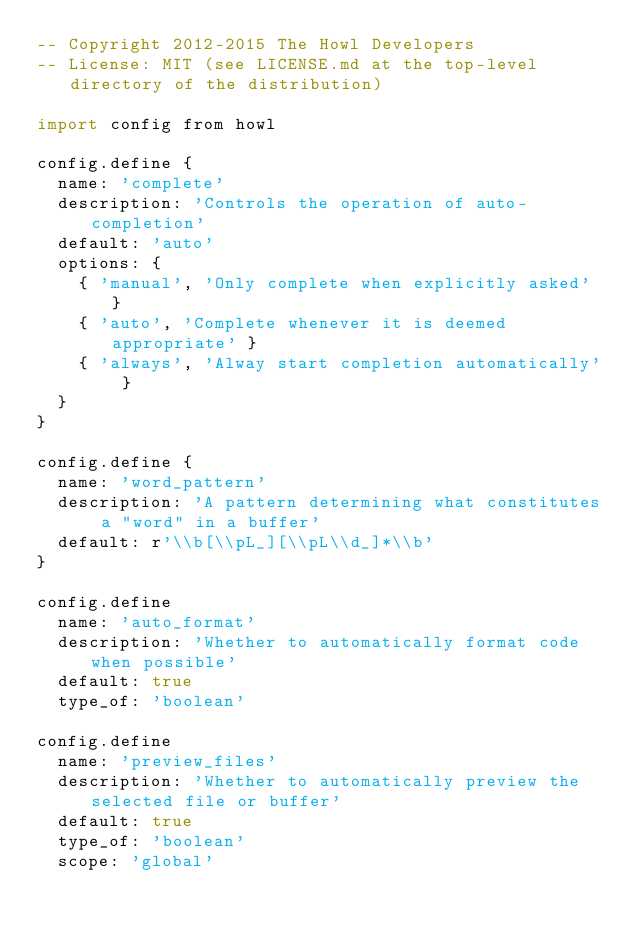<code> <loc_0><loc_0><loc_500><loc_500><_MoonScript_>-- Copyright 2012-2015 The Howl Developers
-- License: MIT (see LICENSE.md at the top-level directory of the distribution)

import config from howl

config.define {
  name: 'complete'
  description: 'Controls the operation of auto-completion'
  default: 'auto'
  options: {
    { 'manual', 'Only complete when explicitly asked' }
    { 'auto', 'Complete whenever it is deemed appropriate' }
    { 'always', 'Alway start completion automatically' }
  }
}

config.define {
  name: 'word_pattern'
  description: 'A pattern determining what constitutes a "word" in a buffer'
  default: r'\\b[\\pL_][\\pL\\d_]*\\b'
}

config.define
  name: 'auto_format'
  description: 'Whether to automatically format code when possible'
  default: true
  type_of: 'boolean'

config.define
  name: 'preview_files'
  description: 'Whether to automatically preview the selected file or buffer'
  default: true
  type_of: 'boolean'
  scope: 'global'
</code> 